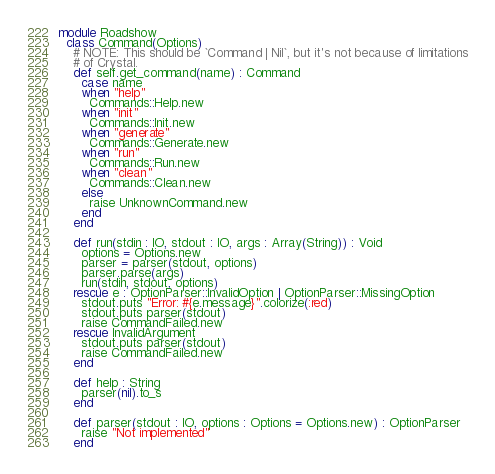Convert code to text. <code><loc_0><loc_0><loc_500><loc_500><_Crystal_>module Roadshow
  class Command(Options)
    # NOTE: This should be `Command | Nil`, but it's not because of limitations
    # of Crystal.
    def self.get_command(name) : Command
      case name
      when "help"
        Commands::Help.new
      when "init"
        Commands::Init.new
      when "generate"
        Commands::Generate.new
      when "run"
        Commands::Run.new
      when "clean"
        Commands::Clean.new
      else
        raise UnknownCommand.new
      end
    end

    def run(stdin : IO, stdout : IO, args : Array(String)) : Void
      options = Options.new
      parser = parser(stdout, options)
      parser.parse(args)
      run(stdin, stdout, options)
    rescue e : OptionParser::InvalidOption | OptionParser::MissingOption
      stdout.puts "Error: #{e.message}".colorize(:red)
      stdout.puts parser(stdout)
      raise CommandFailed.new
    rescue InvalidArgument
      stdout.puts parser(stdout)
      raise CommandFailed.new
    end

    def help : String
      parser(nil).to_s
    end

    def parser(stdout : IO, options : Options = Options.new) : OptionParser
      raise "Not implemented"
    end
</code> 